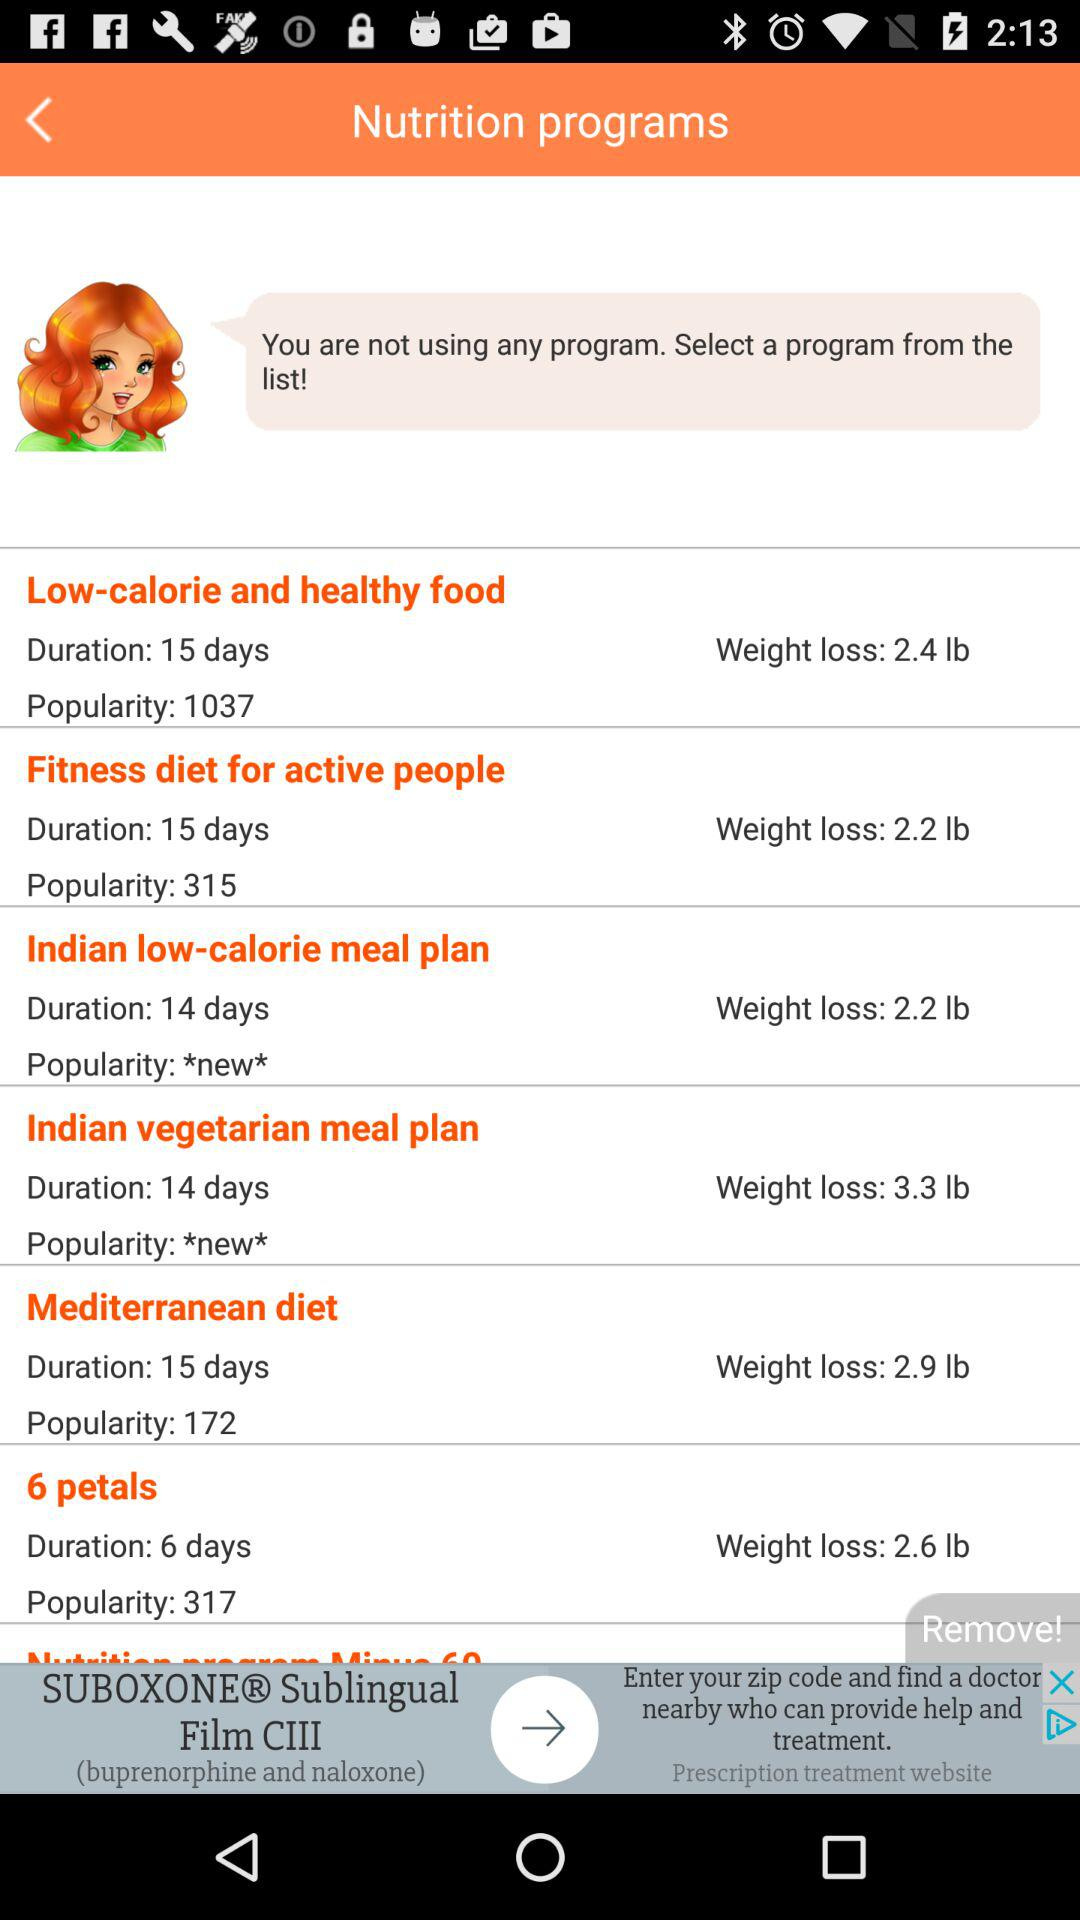What is the duration of the "Fitness diet for active people"? The duration of the "Fitness diet for active people" is 15 days. 